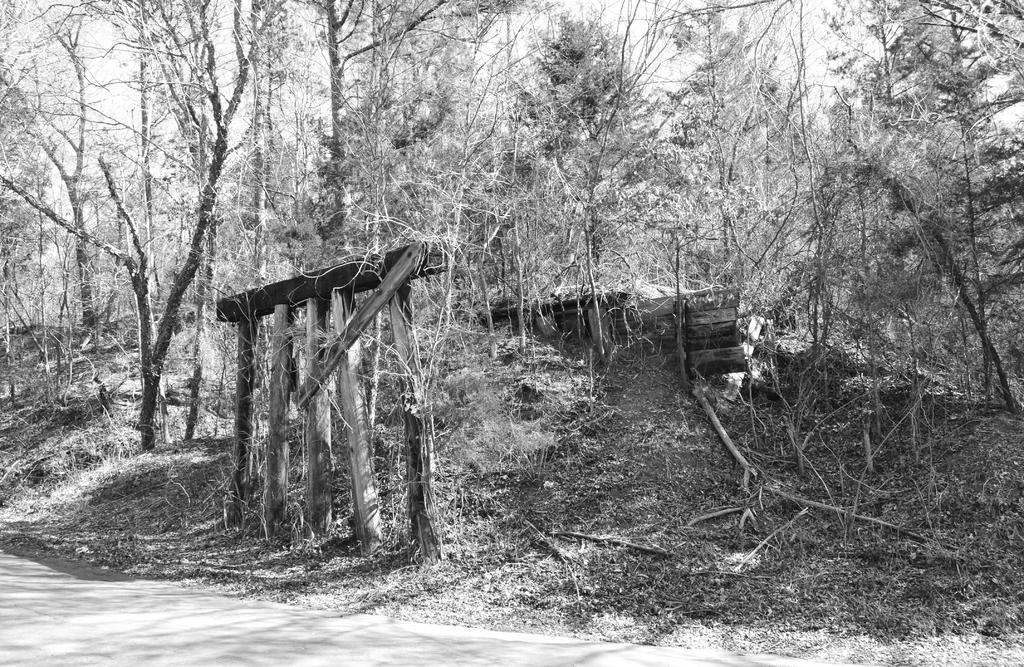What is the color scheme of the image? The image is black and white. What type of natural elements can be seen in the image? There are trees in the image. What man-made feature is present in the image? There is a road in the image. What type of arch can be seen in the image? There is no arch present in the image; it features trees and a road in a black and white color scheme. 